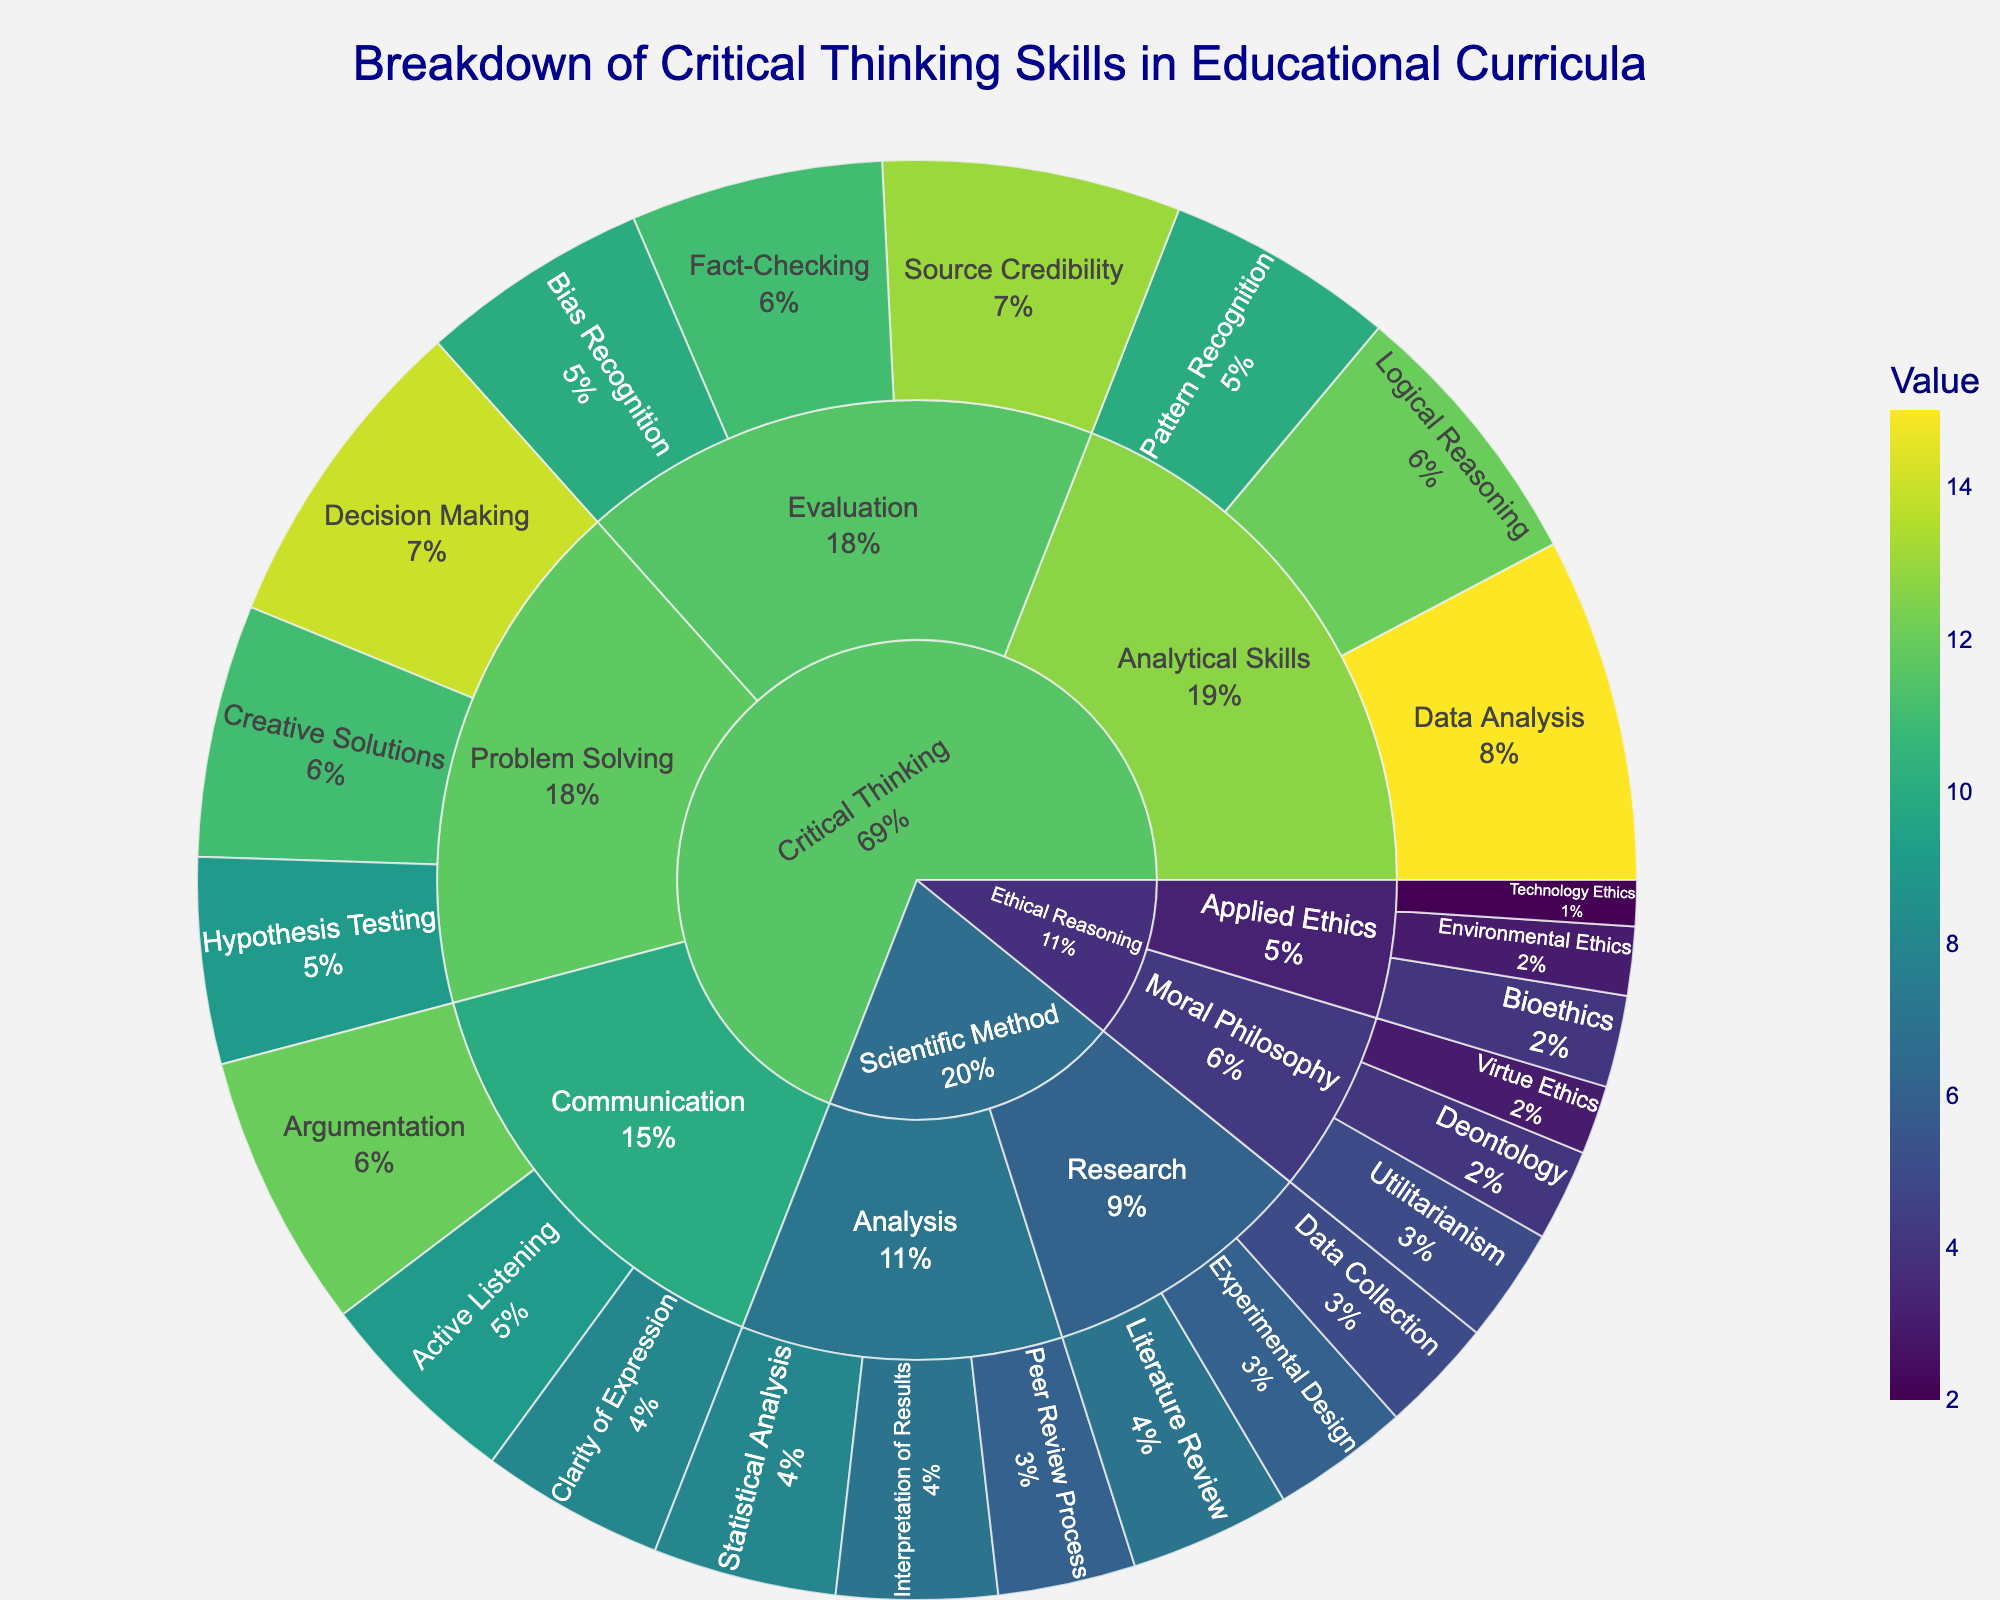What is the title of the figure? The title is located at the top center of the figure and it reads, 'Breakdown of Critical Thinking Skills in Educational Curricula'.
Answer: Breakdown of Critical Thinking Skills in Educational Curricula How many subcategories are under the main category 'Critical Thinking'? By examining the sunburst plot, we see that the main category 'Critical Thinking' expands into four subcategories: 'Analytical Skills', 'Problem Solving', 'Evaluation', and 'Communication'.
Answer: Four Which skill within 'Problem Solving' has the highest value? The sunburst plot shows that 'Problem Solving' has three skills: 'Decision Making', 'Creative Solutions', and 'Hypothesis Testing'. 'Decision Making' has the highest value of 14.
Answer: Decision Making What is the total value of all skills grouped under 'Ethical Reasoning'? To find the total value, add the values of each skill under 'Ethical Reasoning': Utilitarianism (5), Deontology (4), Virtue Ethics (3), Bioethics (4), Environmental Ethics (3), Technology Ethics (2). Summing these values: 5 + 4 + 3 + 4 + 3 + 2 = 21.
Answer: 21 Which main category contributes the most to critical thinking skills in the educational curricula, based on the values? 'Critical Thinking' has the highest sum of values when compared with 'Scientific Method' and 'Ethical Reasoning'. Summing the values for 'Critical Thinking' gives the largest total value.
Answer: Critical Thinking Which subcategory under 'Scientific Method' has the least total value? The subcategories under 'Scientific Method' are 'Research' and 'Analysis'. The total values for each are: Research = Literature Review (7) + Experimental Design (6) + Data Collection (5) = 18; Analysis = Statistical Analysis (8) + Interpretation of Results (7) + Peer Review Process (6) = 21. Thus, 'Research' has the least total value.
Answer: Research Compare the values of 'Argumentation' and 'Statistical Analysis'. Which one is higher? 'Argumentation' has a value of 12, and 'Statistical Analysis' has a value of 8. Therefore, 'Argumentation' is higher.
Answer: Argumentation What percentage of the subcategory 'Analytical Skills' is made up by 'Data Analysis'? The values in 'Analytical Skills' are: Data Analysis (15), Logical Reasoning (12), and Pattern Recognition (10). The total is 15 + 12 + 10 = 37. The percentage for 'Data Analysis' is (15/37) * 100 ≈ 40.54%.
Answer: 40.54% Which skill within 'Ethical Reasoning' has the lowest value? By examining the skills within 'Ethical Reasoning', we see that 'Technology Ethics' has the lowest value of 2.
Answer: Technology Ethics 